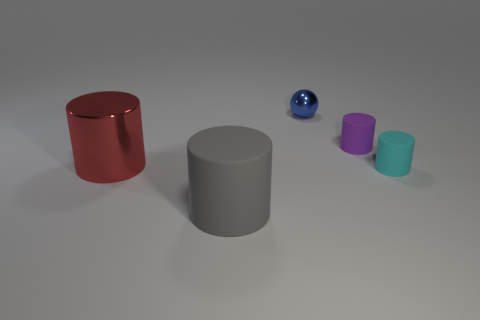Subtract 1 cylinders. How many cylinders are left? 3 Add 4 blue spheres. How many objects exist? 9 Subtract all balls. How many objects are left? 4 Subtract all small blue objects. Subtract all tiny gray objects. How many objects are left? 4 Add 2 rubber objects. How many rubber objects are left? 5 Add 2 gray cylinders. How many gray cylinders exist? 3 Subtract 0 purple cubes. How many objects are left? 5 